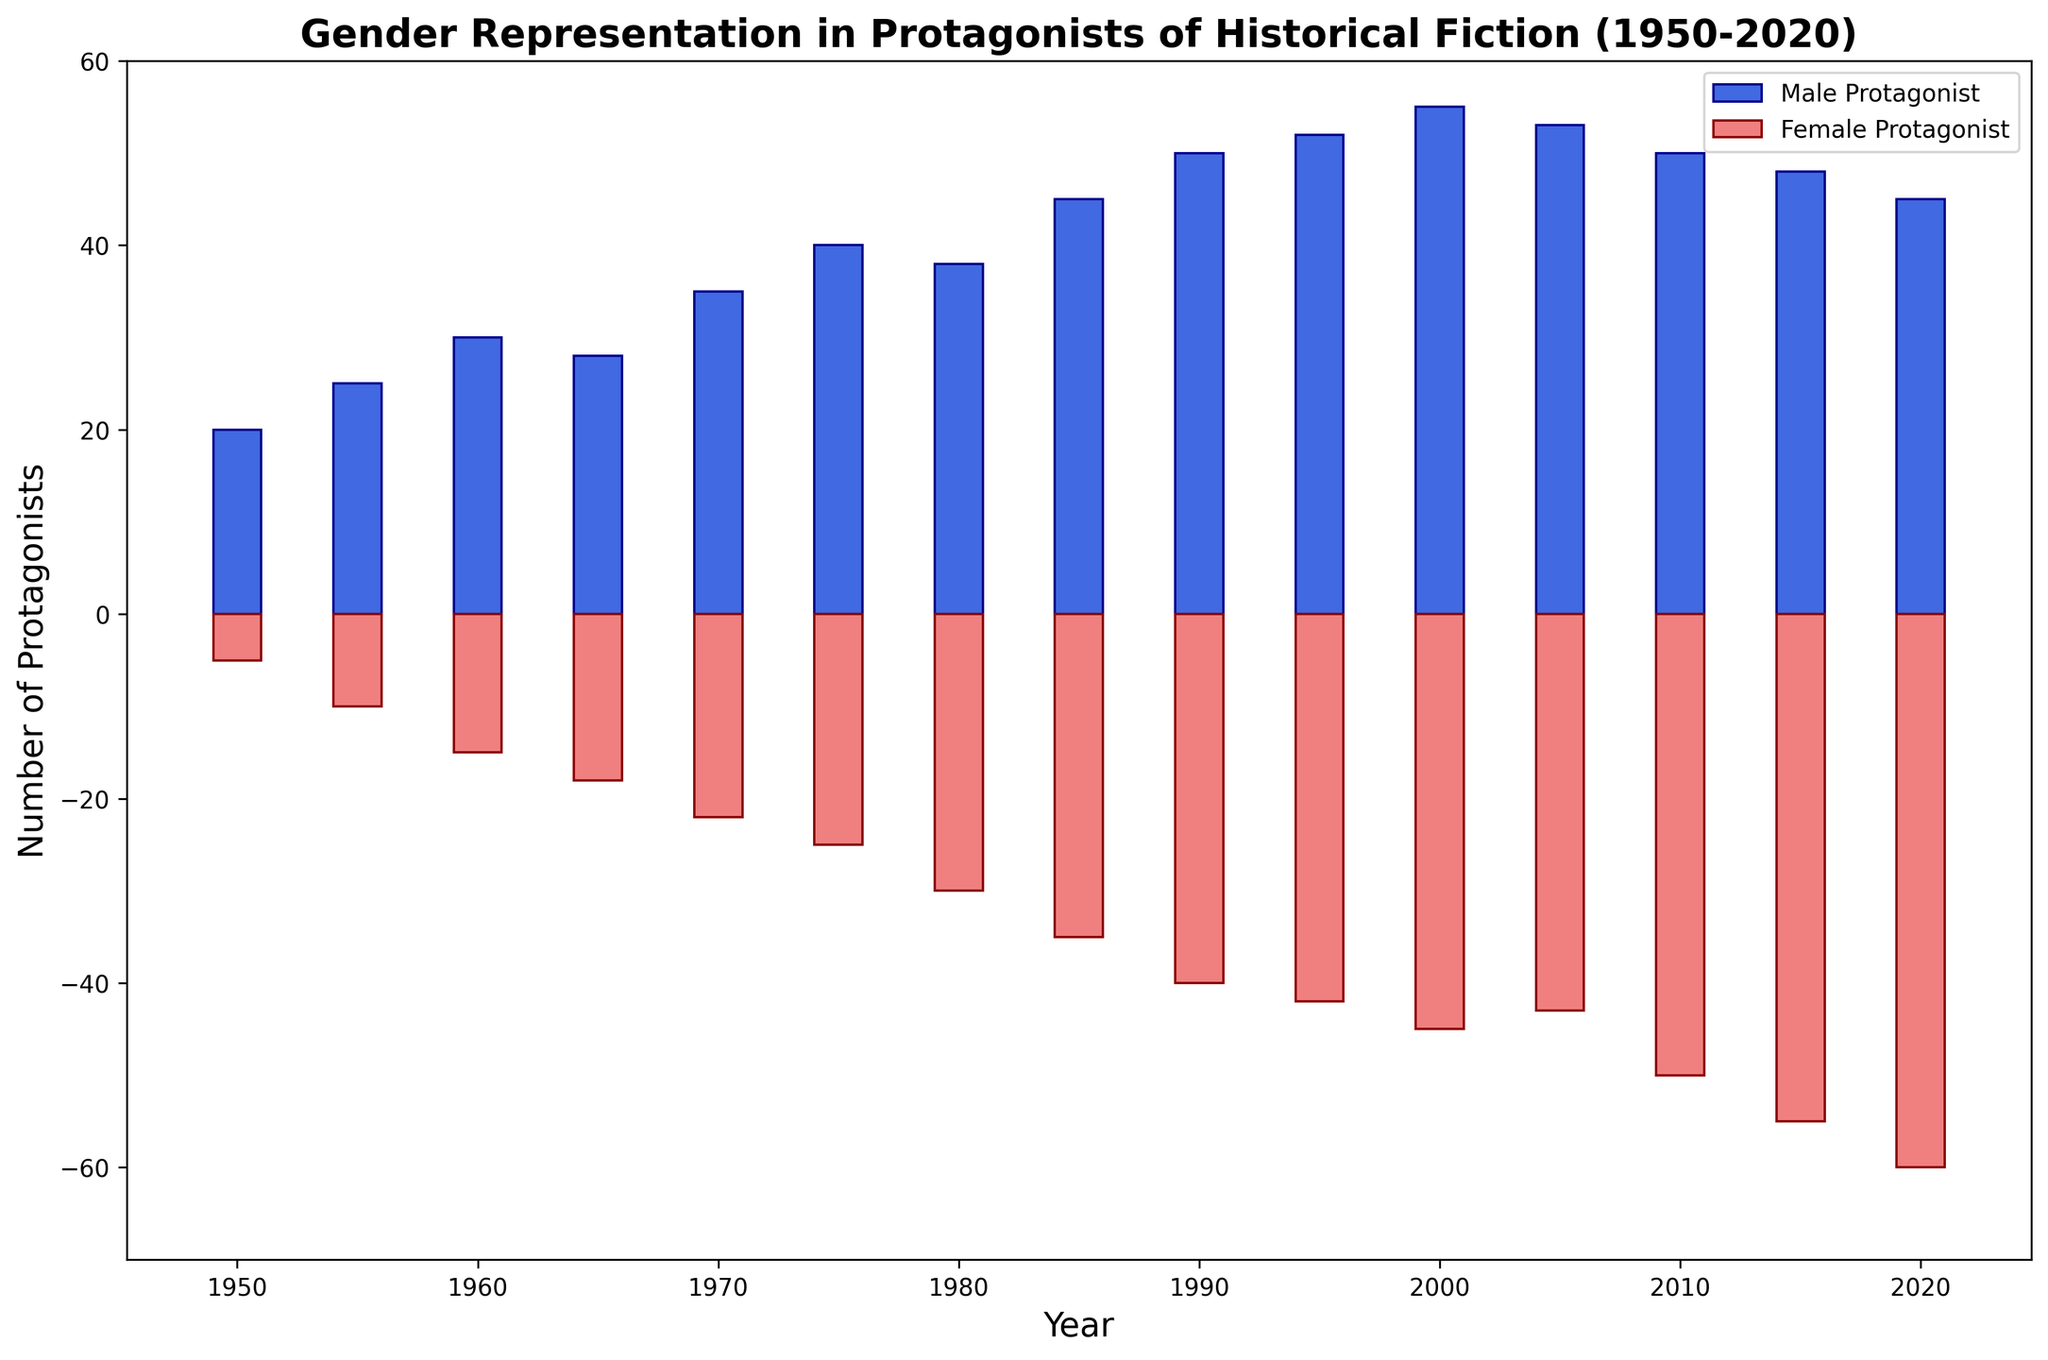What is the general trend in the representation of male protagonists from 1950 to 2020? The bar heights for male protagonists increase over time, indicating a general upward trend in the number of male leads from 1950 to 2020.
Answer: Upward trend Which year recorded the highest number of male protagonists? By examining the heights of the bars, the highest bar for male protagonists is in the year 2000.
Answer: 2000 How does the number of female protagonists in 1980 compare to that in 1990? The bar for female protagonists in 1980 is at -30, whereas in 1990, it is at -40. Thus, there were more female protagonists in 1980 compared to 1990.
Answer: 1980 What is the difference in the number of male protagonists between 1965 and 1975? The male leads in 1965 are 28, and in 1975, they are 40. The difference is 40 - 28 = 12.
Answer: 12 What colors represent male and female protagonists in the bar chart? The male protagonists are represented in blue (royalblue), and the female protagonists are represented in red (lightcoral).
Answer: Blue and Red How do the trends of male and female protagonists compare between 2000 and 2020? From 2000 to 2020, male protagonists slightly decrease from 55 to 45, while female protagonists increase from -45 to -60. This shows a decreasing trend for male leads and an increasing trend for female leads.
Answer: Male decrease, Female increase What is the sum of male protagonists recorded in the years 1985 and 1995? Male protagonists in 1985 are 45 and in 1995 are 52. Sum = 45 + 52 = 97.
Answer: 97 What is the average number of male protagonists from 2000 to 2020? Male protagonists from 2000 to 2020 are 55, 53, 50, 48, and 45. Sum these figures: 55 + 53 + 50 + 48 + 45 = 251. The average is 251 / 5 = 50.2.
Answer: 50.2 